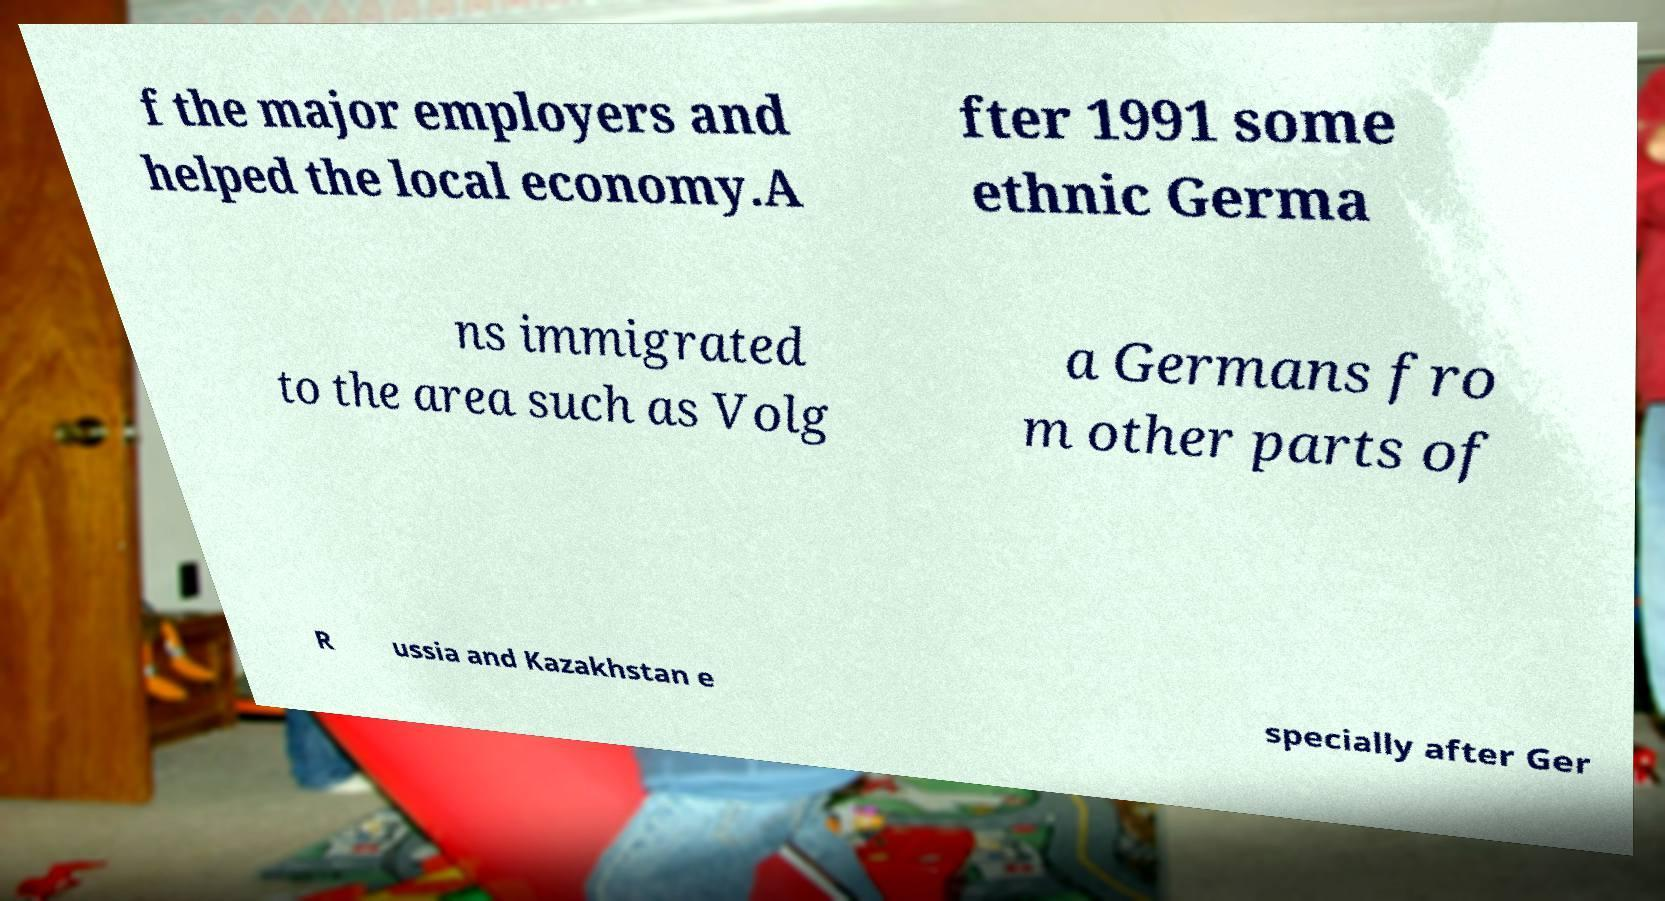Could you extract and type out the text from this image? f the major employers and helped the local economy.A fter 1991 some ethnic Germa ns immigrated to the area such as Volg a Germans fro m other parts of R ussia and Kazakhstan e specially after Ger 